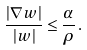Convert formula to latex. <formula><loc_0><loc_0><loc_500><loc_500>\frac { | \nabla w | } { | w | } \leq \frac { \alpha } { \rho } \, .</formula> 